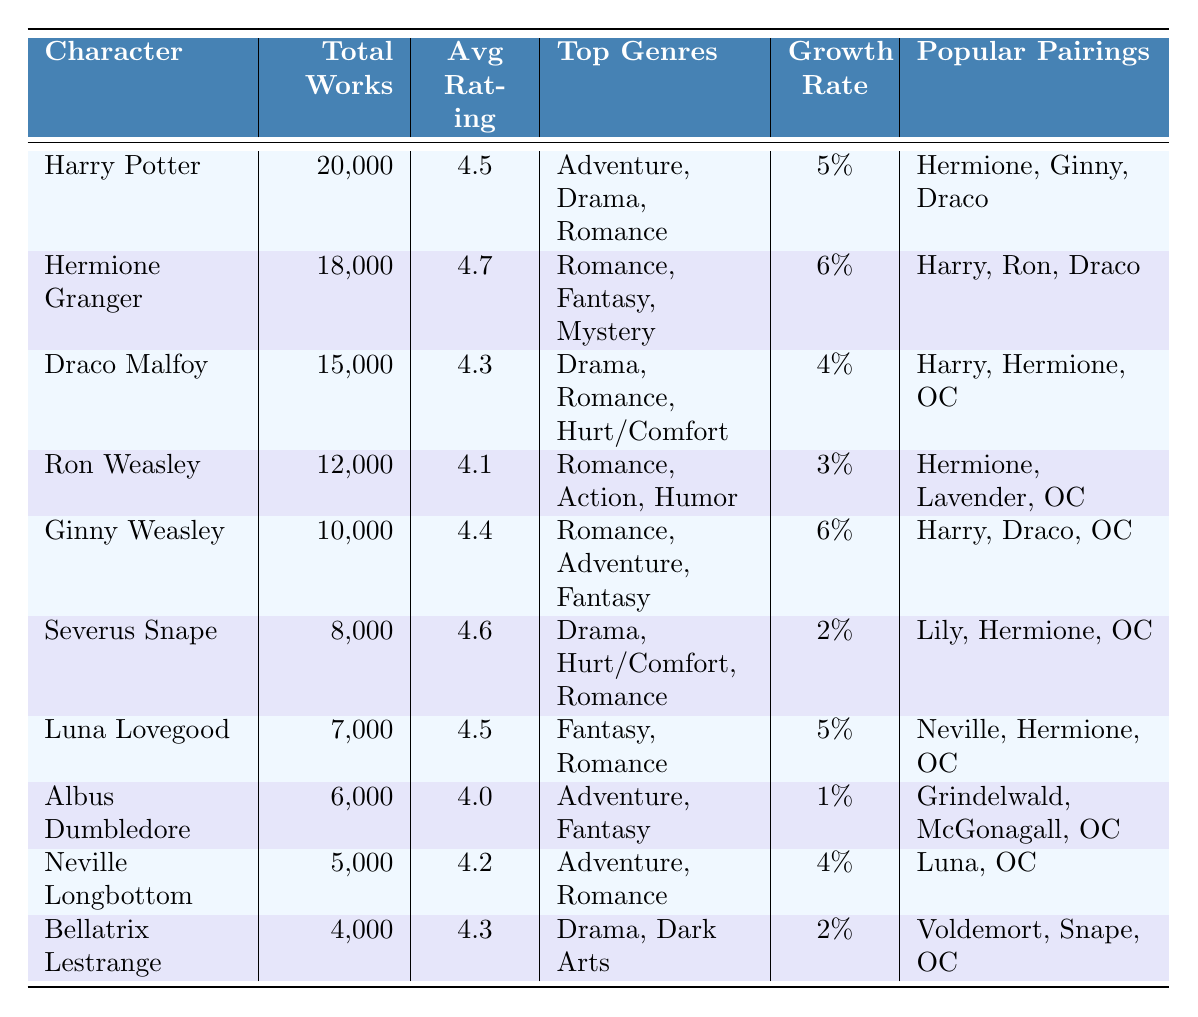What character has the highest average rating? By examining the "Average Rating" column, Hermione Granger has the highest average rating of 4.7.
Answer: Hermione Granger How many total fanfiction works feature Ron Weasley? The "Total Works" column shows that Ron Weasley has a total of 12,000 fanfiction works.
Answer: 12,000 Which character has the lowest growth rate in fanworks? Looking at the "Growth Rate" column, Albus Dumbledore has the lowest growth rate at 1%.
Answer: Albus Dumbledore What are the top genres for Draco Malfoy? The "Top Genres" column indicates that for Draco Malfoy, the top genres are Drama, Romance, and Hurt/Comfort.
Answer: Drama, Romance, Hurt/Comfort Calculate the average total fanfiction works for the top three characters. The top three characters by total works are Harry Potter (20,000), Hermione Granger (18,000), and Draco Malfoy (15,000). Their total is 20,000 + 18,000 + 15,000 = 53,000. Dividing by 3 gives an average of 53,000 / 3 = 17,666.67.
Answer: 17,666.67 Is the total fanfiction works for Luna Lovegood greater than that for Bellatrix Lestrange? Luna Lovegood has 7,000 total works, and Bellatrix Lestrange has 4,000. Since 7,000 is greater than 4,000, the statement is true.
Answer: Yes What character has the same average rating as Luna Lovegood? Both Harry Potter and Luna Lovegood have an average rating of 4.5, as seen in the "Average Rating" column.
Answer: Harry Potter Which character has more than 10,000 total fanfiction works and a growth rate of at least 5%? Harry Potter (20,000 works, 5%), Hermione Granger (18,000 works, 6%), and Ginny Weasley (10,000 works, 6%) all meet these criteria.
Answer: Harry Potter, Hermione Granger, Ginny Weasley What are the popular pairings for Severus Snape? According to the "Popular Pairings" column, Severus Snape's popular pairings are Lily Potter, Hermione Granger, and OC.
Answer: Lily Potter, Hermione Granger, OC Calculate the difference in total fanfiction works between Harry Potter and Albus Dumbledore. Harry Potter has 20,000 works and Albus Dumbledore has 6,000 works. The difference is 20,000 - 6,000 = 14,000.
Answer: 14,000 What percentage of the total fanfiction works does Bellatrix Lestrange represent compared to Harry Potter? Bellatrix Lestrange has 4,000 works and Harry Potter has 20,000 works. The percentage is (4,000 / 20,000) * 100 = 20%.
Answer: 20% 